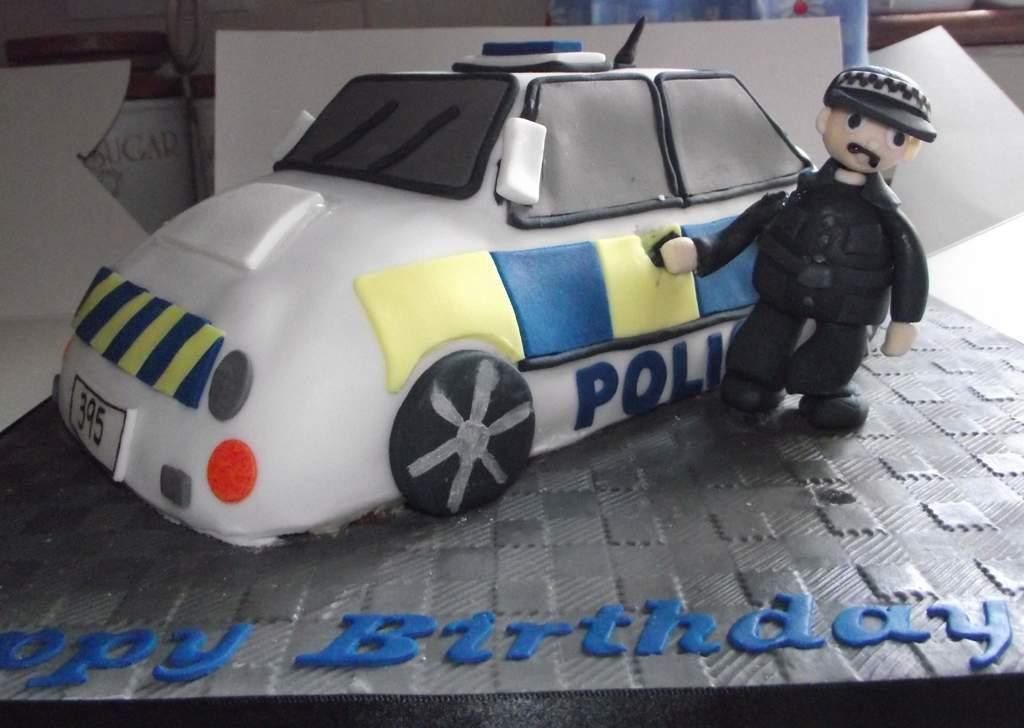What is the main subject of the image? There is a cake in the image. Is there any text present in the image? Yes, there is text at the bottom of the image. How many apples are on the cake in the image? There is no mention of apples in the image, so we cannot determine the number of apples on the cake. What type of utensil is being used to attempt cutting the cake in the image? There is no attempt to cut the cake or any utensil visible in the image. 